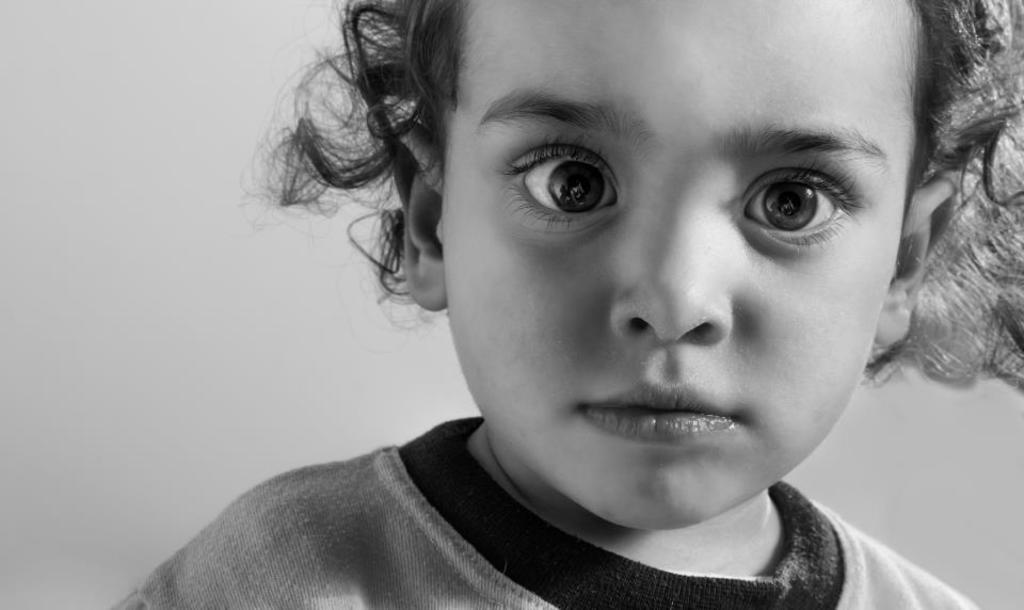What is the main subject of the image? There is a child in the image. Can you describe the perspective of the image? The image is a close-up view of the child. What type of beam is holding up the parent in the image? There is no parent or beam present in the image; it only features a child. 